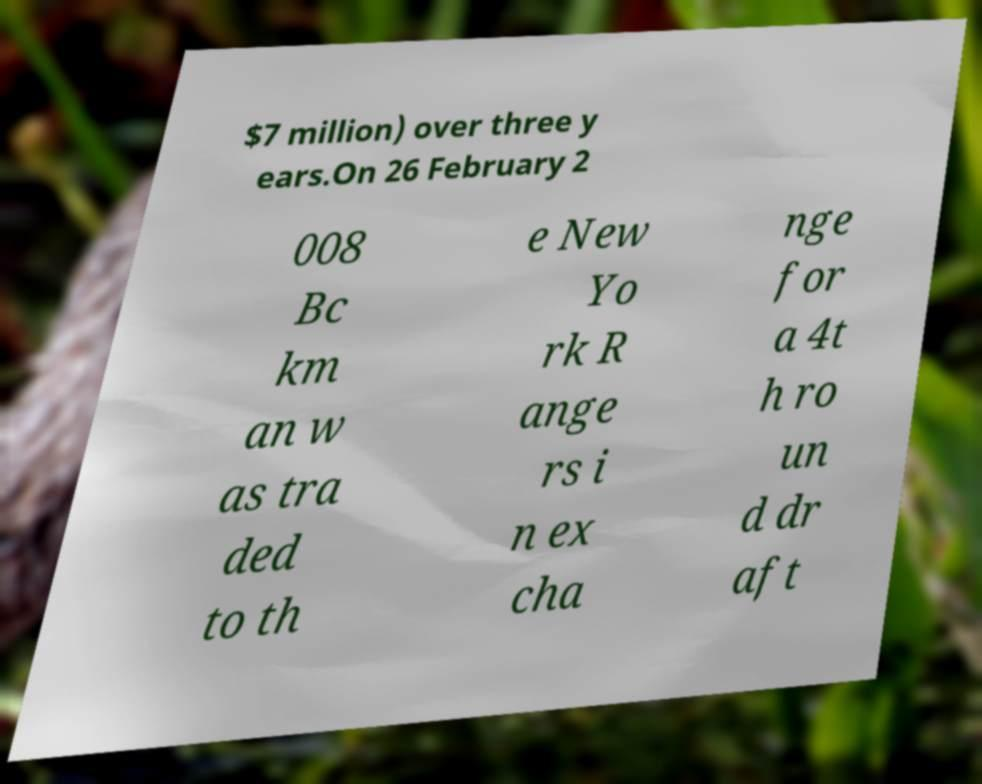Could you assist in decoding the text presented in this image and type it out clearly? $7 million) over three y ears.On 26 February 2 008 Bc km an w as tra ded to th e New Yo rk R ange rs i n ex cha nge for a 4t h ro un d dr aft 